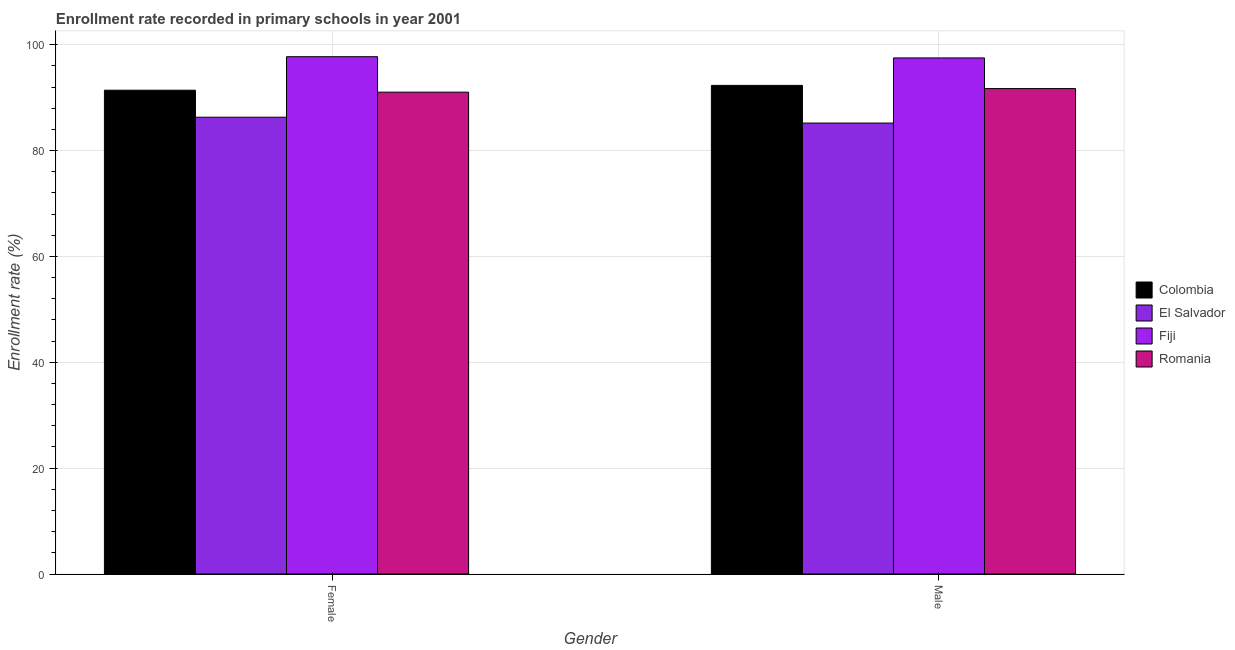How many different coloured bars are there?
Ensure brevity in your answer.  4. Are the number of bars on each tick of the X-axis equal?
Keep it short and to the point. Yes. How many bars are there on the 1st tick from the right?
Offer a very short reply. 4. What is the label of the 1st group of bars from the left?
Your answer should be compact. Female. What is the enrollment rate of male students in Colombia?
Provide a succinct answer. 92.31. Across all countries, what is the maximum enrollment rate of male students?
Your answer should be compact. 97.5. Across all countries, what is the minimum enrollment rate of female students?
Make the answer very short. 86.3. In which country was the enrollment rate of female students maximum?
Your answer should be very brief. Fiji. In which country was the enrollment rate of female students minimum?
Make the answer very short. El Salvador. What is the total enrollment rate of female students in the graph?
Your answer should be compact. 366.47. What is the difference between the enrollment rate of female students in Romania and that in Fiji?
Ensure brevity in your answer.  -6.7. What is the difference between the enrollment rate of male students in Romania and the enrollment rate of female students in Fiji?
Ensure brevity in your answer.  -6.03. What is the average enrollment rate of male students per country?
Make the answer very short. 91.68. What is the difference between the enrollment rate of male students and enrollment rate of female students in Colombia?
Provide a succinct answer. 0.91. What is the ratio of the enrollment rate of female students in Fiji to that in Romania?
Offer a very short reply. 1.07. Is the enrollment rate of male students in Colombia less than that in El Salvador?
Make the answer very short. No. What does the 3rd bar from the left in Female represents?
Provide a succinct answer. Fiji. What does the 2nd bar from the right in Female represents?
Ensure brevity in your answer.  Fiji. How many bars are there?
Keep it short and to the point. 8. Are all the bars in the graph horizontal?
Keep it short and to the point. No. How many countries are there in the graph?
Offer a terse response. 4. What is the difference between two consecutive major ticks on the Y-axis?
Give a very brief answer. 20. Are the values on the major ticks of Y-axis written in scientific E-notation?
Keep it short and to the point. No. Where does the legend appear in the graph?
Make the answer very short. Center right. How many legend labels are there?
Give a very brief answer. 4. How are the legend labels stacked?
Your answer should be very brief. Vertical. What is the title of the graph?
Provide a succinct answer. Enrollment rate recorded in primary schools in year 2001. What is the label or title of the X-axis?
Ensure brevity in your answer.  Gender. What is the label or title of the Y-axis?
Keep it short and to the point. Enrollment rate (%). What is the Enrollment rate (%) of Colombia in Female?
Make the answer very short. 91.4. What is the Enrollment rate (%) in El Salvador in Female?
Provide a short and direct response. 86.3. What is the Enrollment rate (%) in Fiji in Female?
Make the answer very short. 97.73. What is the Enrollment rate (%) in Romania in Female?
Your answer should be very brief. 91.03. What is the Enrollment rate (%) of Colombia in Male?
Offer a terse response. 92.31. What is the Enrollment rate (%) in El Salvador in Male?
Make the answer very short. 85.2. What is the Enrollment rate (%) in Fiji in Male?
Give a very brief answer. 97.5. What is the Enrollment rate (%) in Romania in Male?
Your response must be concise. 91.71. Across all Gender, what is the maximum Enrollment rate (%) in Colombia?
Your answer should be compact. 92.31. Across all Gender, what is the maximum Enrollment rate (%) in El Salvador?
Ensure brevity in your answer.  86.3. Across all Gender, what is the maximum Enrollment rate (%) in Fiji?
Ensure brevity in your answer.  97.73. Across all Gender, what is the maximum Enrollment rate (%) of Romania?
Make the answer very short. 91.71. Across all Gender, what is the minimum Enrollment rate (%) in Colombia?
Ensure brevity in your answer.  91.4. Across all Gender, what is the minimum Enrollment rate (%) in El Salvador?
Give a very brief answer. 85.2. Across all Gender, what is the minimum Enrollment rate (%) of Fiji?
Give a very brief answer. 97.5. Across all Gender, what is the minimum Enrollment rate (%) in Romania?
Provide a short and direct response. 91.03. What is the total Enrollment rate (%) of Colombia in the graph?
Your response must be concise. 183.71. What is the total Enrollment rate (%) of El Salvador in the graph?
Provide a succinct answer. 171.5. What is the total Enrollment rate (%) in Fiji in the graph?
Your answer should be compact. 195.23. What is the total Enrollment rate (%) in Romania in the graph?
Provide a short and direct response. 182.74. What is the difference between the Enrollment rate (%) of Colombia in Female and that in Male?
Your response must be concise. -0.91. What is the difference between the Enrollment rate (%) in El Salvador in Female and that in Male?
Give a very brief answer. 1.1. What is the difference between the Enrollment rate (%) of Fiji in Female and that in Male?
Offer a terse response. 0.24. What is the difference between the Enrollment rate (%) of Romania in Female and that in Male?
Make the answer very short. -0.68. What is the difference between the Enrollment rate (%) in Colombia in Female and the Enrollment rate (%) in El Salvador in Male?
Your answer should be compact. 6.2. What is the difference between the Enrollment rate (%) of Colombia in Female and the Enrollment rate (%) of Fiji in Male?
Your answer should be compact. -6.1. What is the difference between the Enrollment rate (%) in Colombia in Female and the Enrollment rate (%) in Romania in Male?
Provide a succinct answer. -0.31. What is the difference between the Enrollment rate (%) in El Salvador in Female and the Enrollment rate (%) in Fiji in Male?
Provide a succinct answer. -11.2. What is the difference between the Enrollment rate (%) in El Salvador in Female and the Enrollment rate (%) in Romania in Male?
Your response must be concise. -5.41. What is the difference between the Enrollment rate (%) of Fiji in Female and the Enrollment rate (%) of Romania in Male?
Provide a succinct answer. 6.03. What is the average Enrollment rate (%) in Colombia per Gender?
Your answer should be very brief. 91.86. What is the average Enrollment rate (%) of El Salvador per Gender?
Give a very brief answer. 85.75. What is the average Enrollment rate (%) of Fiji per Gender?
Your answer should be compact. 97.62. What is the average Enrollment rate (%) in Romania per Gender?
Ensure brevity in your answer.  91.37. What is the difference between the Enrollment rate (%) in Colombia and Enrollment rate (%) in El Salvador in Female?
Make the answer very short. 5.1. What is the difference between the Enrollment rate (%) in Colombia and Enrollment rate (%) in Fiji in Female?
Ensure brevity in your answer.  -6.33. What is the difference between the Enrollment rate (%) in Colombia and Enrollment rate (%) in Romania in Female?
Make the answer very short. 0.37. What is the difference between the Enrollment rate (%) of El Salvador and Enrollment rate (%) of Fiji in Female?
Make the answer very short. -11.43. What is the difference between the Enrollment rate (%) of El Salvador and Enrollment rate (%) of Romania in Female?
Ensure brevity in your answer.  -4.73. What is the difference between the Enrollment rate (%) of Fiji and Enrollment rate (%) of Romania in Female?
Your response must be concise. 6.7. What is the difference between the Enrollment rate (%) of Colombia and Enrollment rate (%) of El Salvador in Male?
Provide a succinct answer. 7.12. What is the difference between the Enrollment rate (%) in Colombia and Enrollment rate (%) in Fiji in Male?
Give a very brief answer. -5.19. What is the difference between the Enrollment rate (%) of Colombia and Enrollment rate (%) of Romania in Male?
Keep it short and to the point. 0.6. What is the difference between the Enrollment rate (%) in El Salvador and Enrollment rate (%) in Fiji in Male?
Your response must be concise. -12.3. What is the difference between the Enrollment rate (%) of El Salvador and Enrollment rate (%) of Romania in Male?
Provide a short and direct response. -6.51. What is the difference between the Enrollment rate (%) in Fiji and Enrollment rate (%) in Romania in Male?
Provide a succinct answer. 5.79. What is the ratio of the Enrollment rate (%) in Colombia in Female to that in Male?
Your response must be concise. 0.99. What is the ratio of the Enrollment rate (%) of Fiji in Female to that in Male?
Provide a short and direct response. 1. What is the ratio of the Enrollment rate (%) in Romania in Female to that in Male?
Offer a very short reply. 0.99. What is the difference between the highest and the second highest Enrollment rate (%) of Colombia?
Make the answer very short. 0.91. What is the difference between the highest and the second highest Enrollment rate (%) in El Salvador?
Offer a terse response. 1.1. What is the difference between the highest and the second highest Enrollment rate (%) of Fiji?
Keep it short and to the point. 0.24. What is the difference between the highest and the second highest Enrollment rate (%) in Romania?
Provide a short and direct response. 0.68. What is the difference between the highest and the lowest Enrollment rate (%) in Colombia?
Keep it short and to the point. 0.91. What is the difference between the highest and the lowest Enrollment rate (%) of El Salvador?
Your response must be concise. 1.1. What is the difference between the highest and the lowest Enrollment rate (%) of Fiji?
Make the answer very short. 0.24. What is the difference between the highest and the lowest Enrollment rate (%) of Romania?
Offer a very short reply. 0.68. 